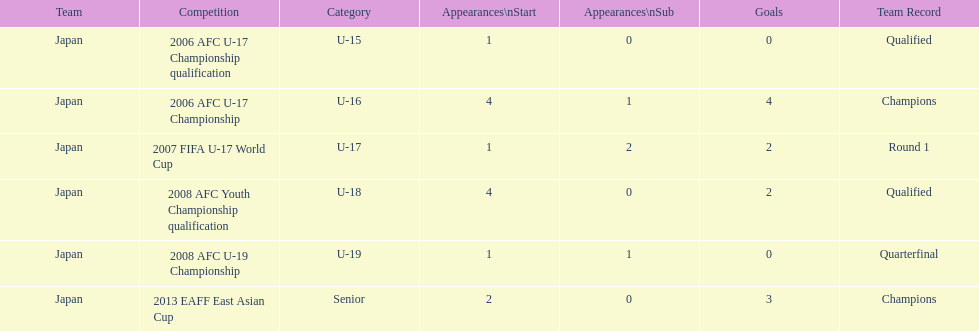In which contest were the greatest number of starts and goals recorded? 2006 AFC U-17 Championship. 